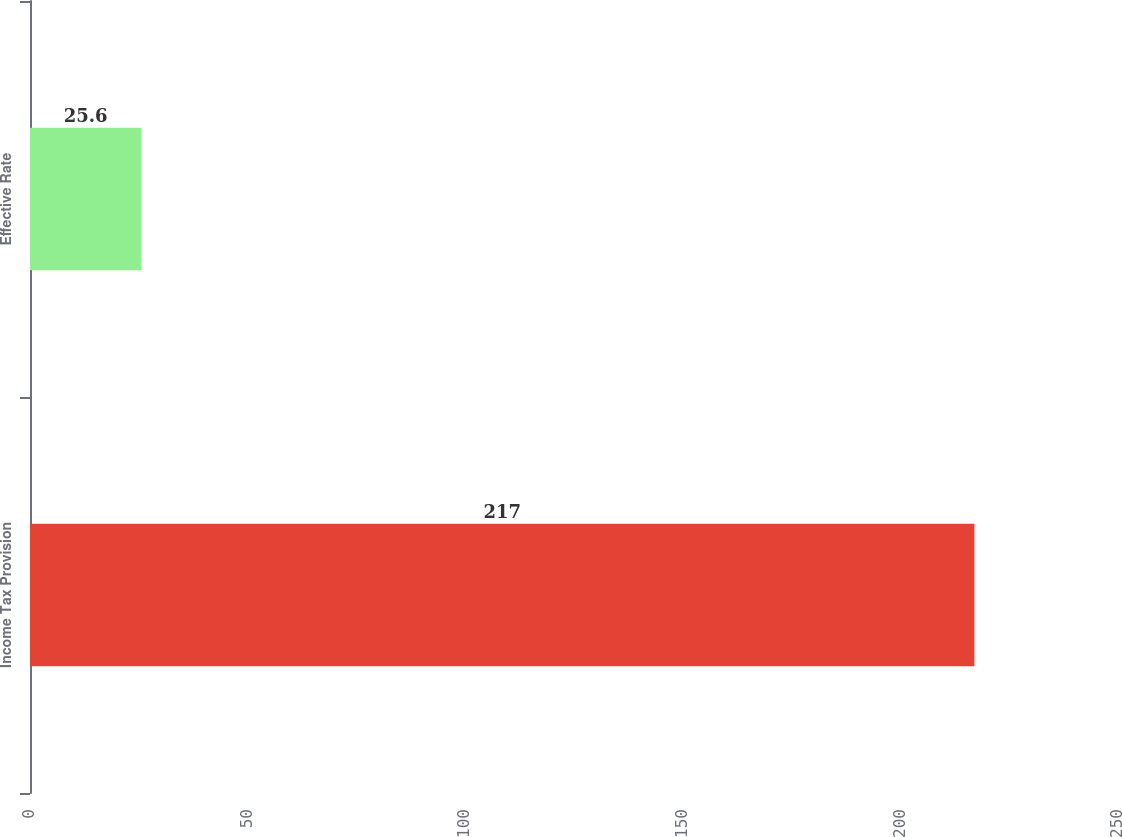Convert chart to OTSL. <chart><loc_0><loc_0><loc_500><loc_500><bar_chart><fcel>Income Tax Provision<fcel>Effective Rate<nl><fcel>217<fcel>25.6<nl></chart> 